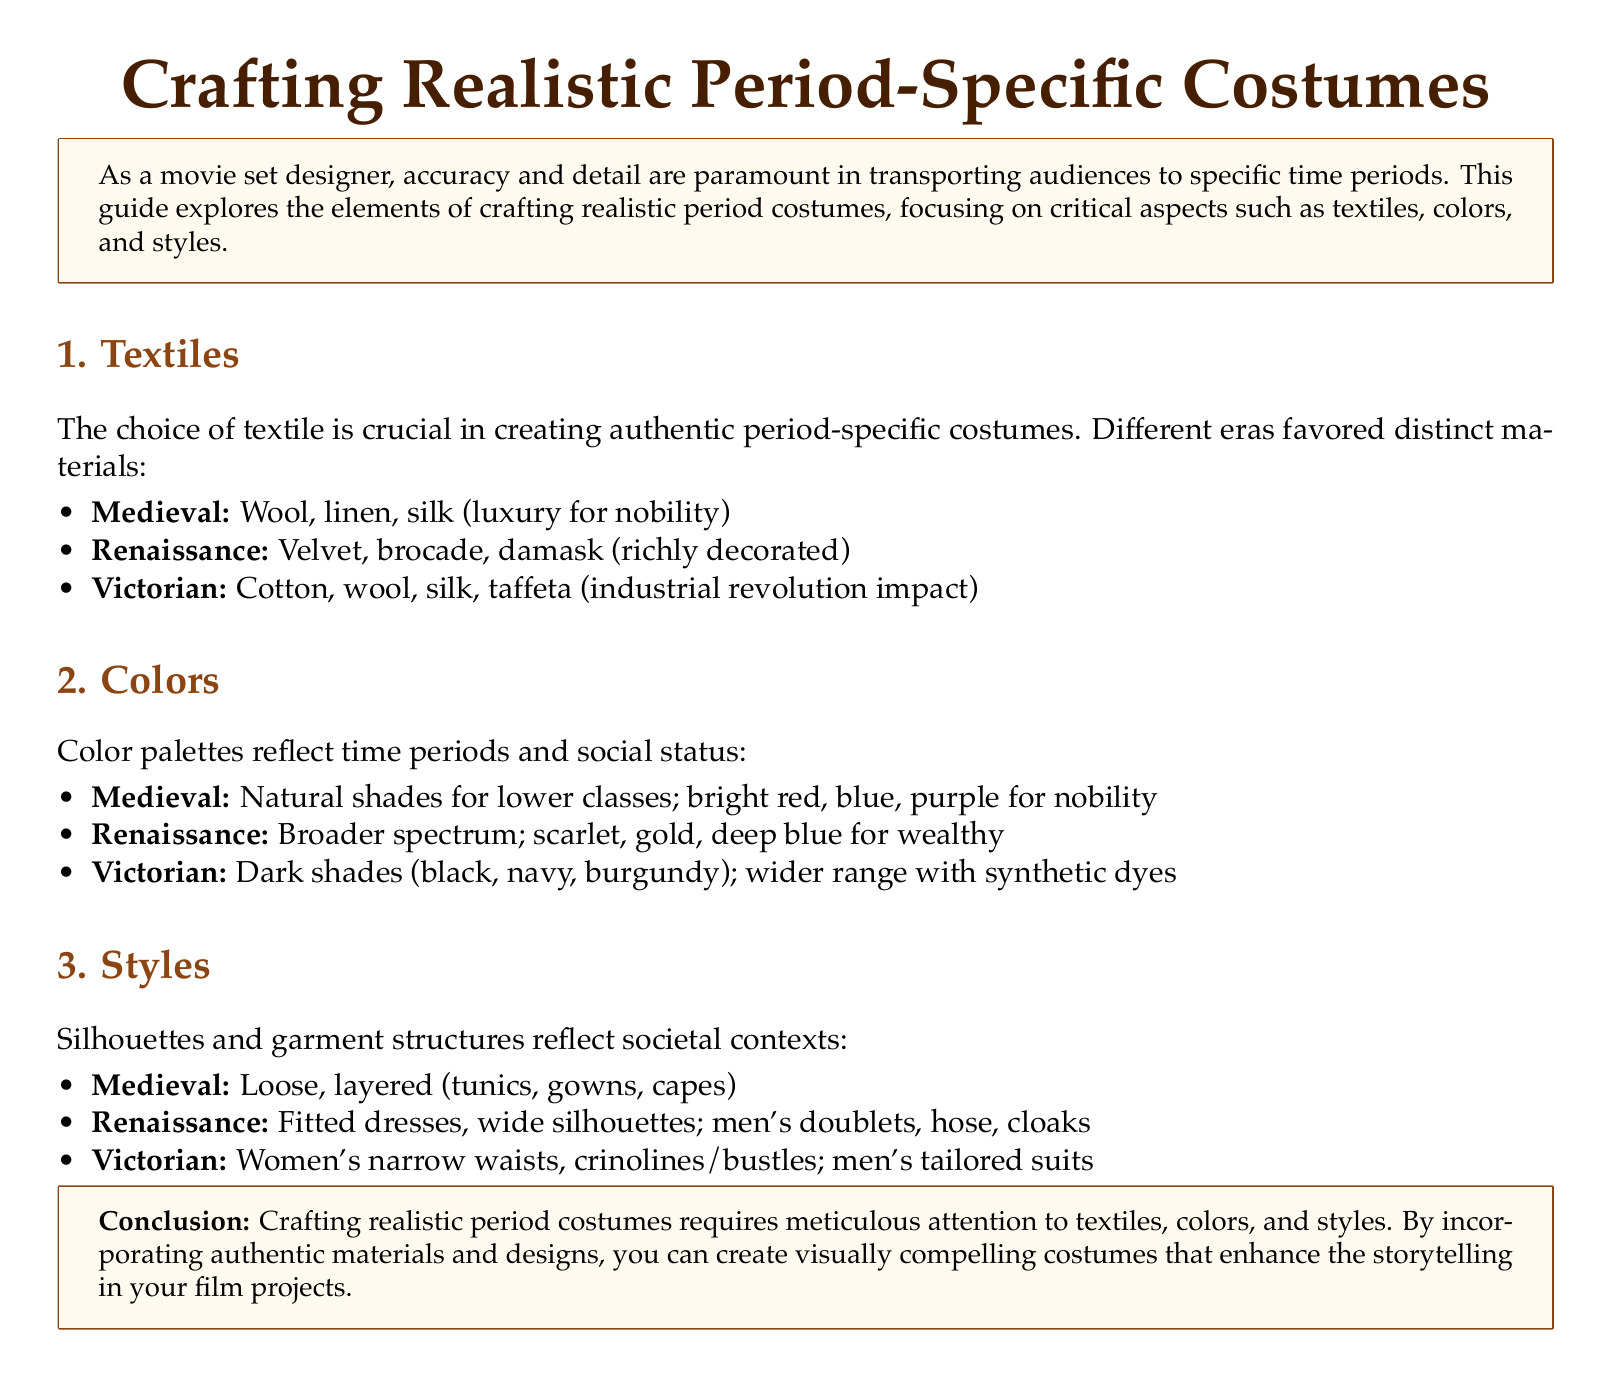What textiles were favored in the Medieval period? The Medieval period favored wool, linen, and silk (luxury for nobility).
Answer: Wool, linen, silk What color palette reflects the Renaissance period? The Renaissance period had a broader spectrum including scarlet, gold, and deep blue for the wealthy.
Answer: Scarlet, gold, deep blue What is the typical silhouette for Victorian women's costumes? Victorian women's costumes typically featured narrow waists, crinolines, and bustles.
Answer: Narrow waists, crinolines, bustles Which textile became important due to the industrial revolution? The industrial revolution impacted costume design by introducing cotton and synthetic materials in the Victorian era.
Answer: Cotton, synthetic materials What was a luxury textile for nobility in the Medieval period? Silk was considered a luxury textile for nobility during the Medieval period.
Answer: Silk What is a common design feature of Renaissance men's fashion? Renaissance men's fashion commonly included doublets and hose.
Answer: Doublets, hose What does crafting realistic period costumes require attention to? Crafting realistic period costumes requires meticulous attention to textiles, colors, and styles.
Answer: Textiles, colors, styles Which time period is characterized by dark shades like burgundy? The Victorian period is characterized by dark shades such as black, navy, and burgundy.
Answer: Victorian What type of document is "Crafting Realistic Period-Specific Costumes"? It is a comprehensive guide focused on period-specific costume design.
Answer: Comprehensive guide 